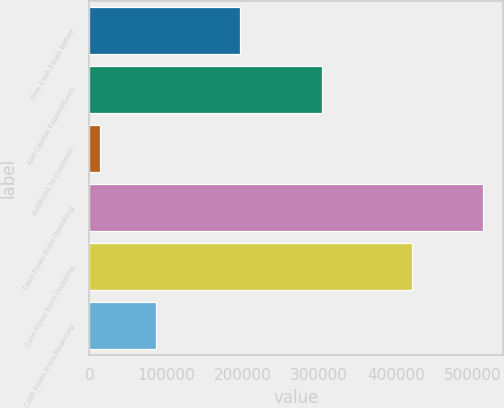<chart> <loc_0><loc_0><loc_500><loc_500><bar_chart><fcel>Free Cash Flows before<fcel>Add Capital Expenditures<fcel>Additions to Customer<fcel>Cash Flows From Operating<fcel>Cash Flows From Investing<fcel>Cash Flows From Financing<nl><fcel>196522<fcel>303236<fcel>14141<fcel>513899<fcel>421480<fcel>87028<nl></chart> 